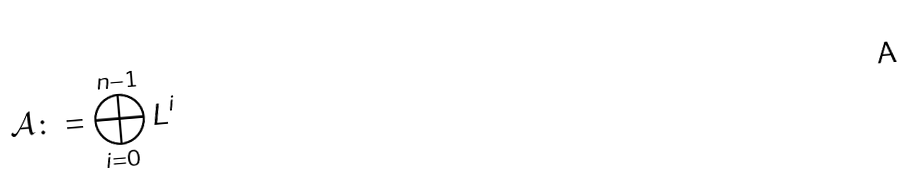<formula> <loc_0><loc_0><loc_500><loc_500>\mathcal { A } \colon = \bigoplus _ { i = 0 } ^ { n - 1 } L ^ { i }</formula> 